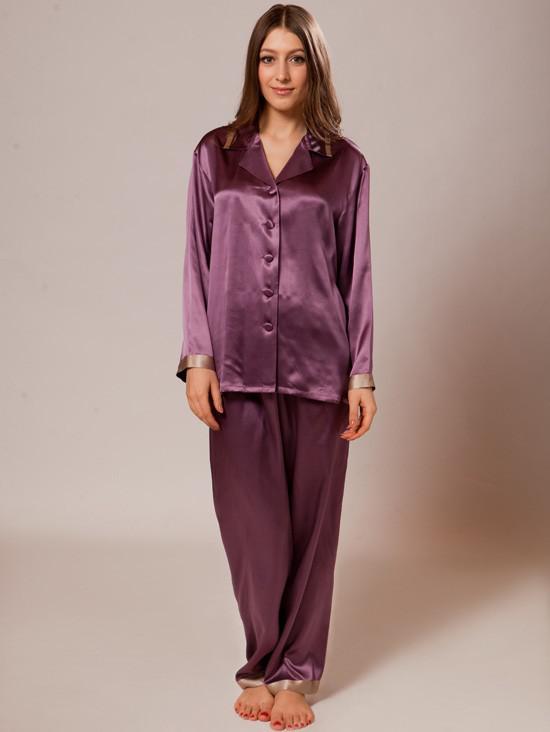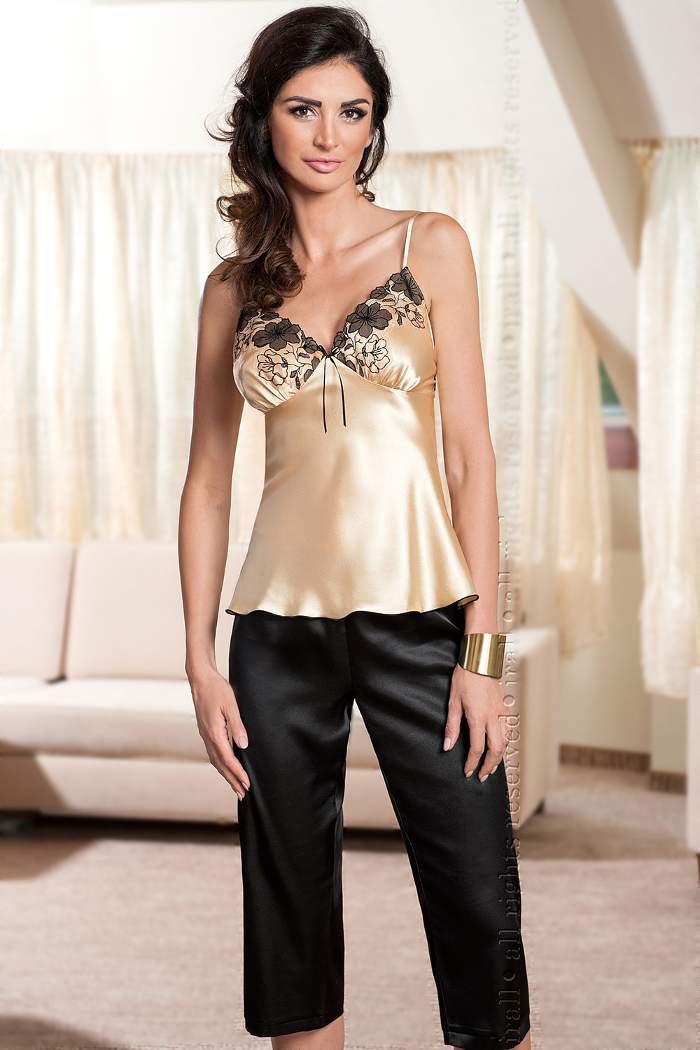The first image is the image on the left, the second image is the image on the right. Examine the images to the left and right. Is the description "In one image, a woman is wearing purple pajamas" accurate? Answer yes or no. Yes. 